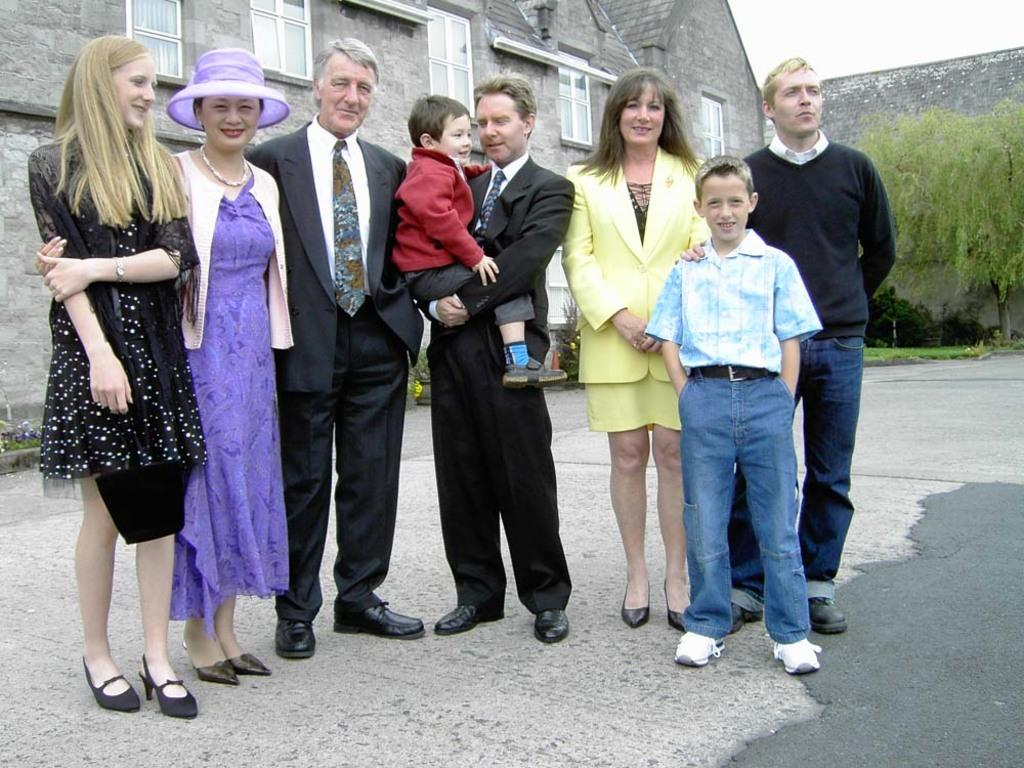What are the people in the image doing? The people in the image are standing on the ground and smiling. What can be seen in the background of the image? There is a building, a window, a tree, and the sky visible in the image. Can you see a rifle in the hands of the people in the image? No, there is no rifle present in the image. Is the grandmother in the image teaching the group of people how to jump? There is no grandmother or any indication of jumping in the image. 